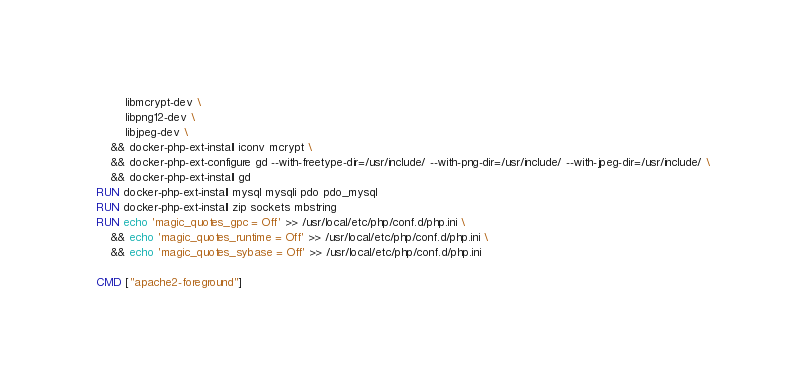<code> <loc_0><loc_0><loc_500><loc_500><_Dockerfile_>        libmcrypt-dev \
        libpng12-dev \
        libjpeg-dev \
    && docker-php-ext-install iconv mcrypt \
    && docker-php-ext-configure gd --with-freetype-dir=/usr/include/ --with-png-dir=/usr/include/ --with-jpeg-dir=/usr/include/ \
    && docker-php-ext-install gd
RUN docker-php-ext-install mysql mysqli pdo pdo_mysql
RUN docker-php-ext-install zip sockets mbstring
RUN echo 'magic_quotes_gpc = Off' >> /usr/local/etc/php/conf.d/php.ini \
    && echo 'magic_quotes_runtime = Off' >> /usr/local/etc/php/conf.d/php.ini \
    && echo 'magic_quotes_sybase = Off' >> /usr/local/etc/php/conf.d/php.ini

CMD ["apache2-foreground"]
</code> 